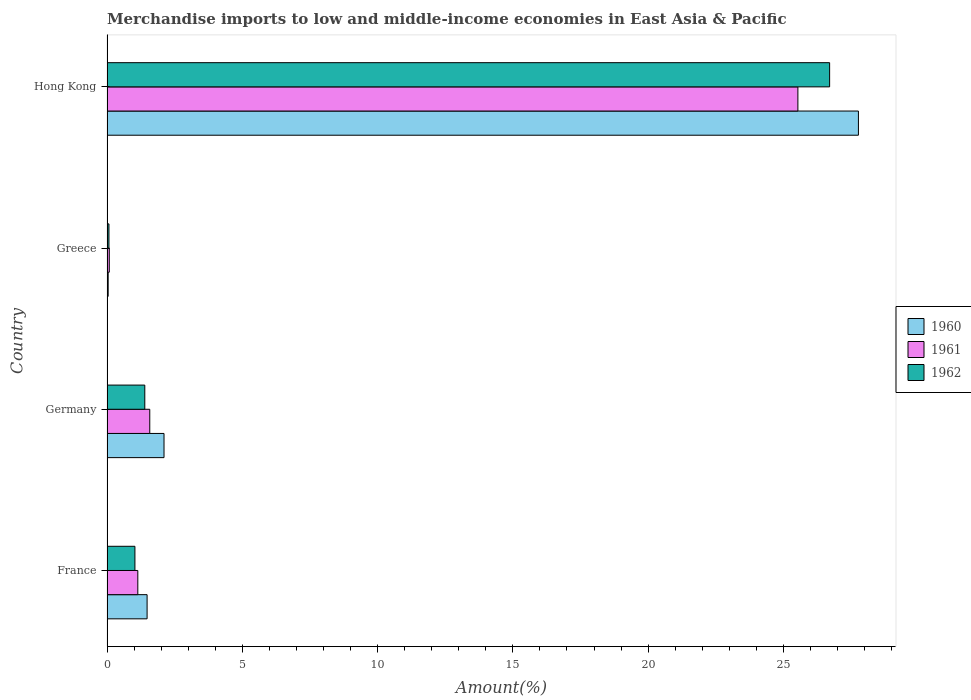How many different coloured bars are there?
Provide a short and direct response. 3. How many groups of bars are there?
Your answer should be very brief. 4. Are the number of bars on each tick of the Y-axis equal?
Provide a short and direct response. Yes. In how many cases, is the number of bars for a given country not equal to the number of legend labels?
Your response must be concise. 0. What is the percentage of amount earned from merchandise imports in 1961 in France?
Offer a very short reply. 1.14. Across all countries, what is the maximum percentage of amount earned from merchandise imports in 1961?
Offer a very short reply. 25.53. Across all countries, what is the minimum percentage of amount earned from merchandise imports in 1960?
Provide a succinct answer. 0.04. In which country was the percentage of amount earned from merchandise imports in 1962 maximum?
Your answer should be compact. Hong Kong. What is the total percentage of amount earned from merchandise imports in 1961 in the graph?
Provide a succinct answer. 28.34. What is the difference between the percentage of amount earned from merchandise imports in 1962 in Germany and that in Greece?
Give a very brief answer. 1.33. What is the difference between the percentage of amount earned from merchandise imports in 1962 in Hong Kong and the percentage of amount earned from merchandise imports in 1960 in France?
Give a very brief answer. 25.23. What is the average percentage of amount earned from merchandise imports in 1961 per country?
Offer a terse response. 7.08. What is the difference between the percentage of amount earned from merchandise imports in 1961 and percentage of amount earned from merchandise imports in 1962 in Greece?
Provide a short and direct response. 0.01. What is the ratio of the percentage of amount earned from merchandise imports in 1960 in Germany to that in Greece?
Provide a succinct answer. 49.05. What is the difference between the highest and the second highest percentage of amount earned from merchandise imports in 1961?
Your answer should be very brief. 23.95. What is the difference between the highest and the lowest percentage of amount earned from merchandise imports in 1962?
Offer a terse response. 26.64. What does the 1st bar from the bottom in Hong Kong represents?
Give a very brief answer. 1960. How many bars are there?
Offer a very short reply. 12. Are all the bars in the graph horizontal?
Provide a succinct answer. Yes. How many legend labels are there?
Give a very brief answer. 3. What is the title of the graph?
Offer a very short reply. Merchandise imports to low and middle-income economies in East Asia & Pacific. Does "2007" appear as one of the legend labels in the graph?
Your answer should be compact. No. What is the label or title of the X-axis?
Offer a terse response. Amount(%). What is the label or title of the Y-axis?
Your response must be concise. Country. What is the Amount(%) in 1960 in France?
Offer a very short reply. 1.48. What is the Amount(%) of 1961 in France?
Your response must be concise. 1.14. What is the Amount(%) of 1962 in France?
Offer a terse response. 1.03. What is the Amount(%) in 1960 in Germany?
Provide a short and direct response. 2.11. What is the Amount(%) in 1961 in Germany?
Provide a short and direct response. 1.58. What is the Amount(%) of 1962 in Germany?
Provide a short and direct response. 1.4. What is the Amount(%) in 1960 in Greece?
Provide a short and direct response. 0.04. What is the Amount(%) of 1961 in Greece?
Offer a terse response. 0.08. What is the Amount(%) of 1962 in Greece?
Offer a very short reply. 0.07. What is the Amount(%) of 1960 in Hong Kong?
Keep it short and to the point. 27.77. What is the Amount(%) in 1961 in Hong Kong?
Offer a very short reply. 25.53. What is the Amount(%) of 1962 in Hong Kong?
Offer a terse response. 26.71. Across all countries, what is the maximum Amount(%) of 1960?
Your answer should be very brief. 27.77. Across all countries, what is the maximum Amount(%) in 1961?
Keep it short and to the point. 25.53. Across all countries, what is the maximum Amount(%) in 1962?
Provide a short and direct response. 26.71. Across all countries, what is the minimum Amount(%) in 1960?
Provide a short and direct response. 0.04. Across all countries, what is the minimum Amount(%) of 1961?
Offer a terse response. 0.08. Across all countries, what is the minimum Amount(%) of 1962?
Keep it short and to the point. 0.07. What is the total Amount(%) in 1960 in the graph?
Ensure brevity in your answer.  31.4. What is the total Amount(%) in 1961 in the graph?
Keep it short and to the point. 28.34. What is the total Amount(%) of 1962 in the graph?
Make the answer very short. 29.21. What is the difference between the Amount(%) of 1960 in France and that in Germany?
Make the answer very short. -0.63. What is the difference between the Amount(%) of 1961 in France and that in Germany?
Your answer should be compact. -0.44. What is the difference between the Amount(%) of 1962 in France and that in Germany?
Give a very brief answer. -0.36. What is the difference between the Amount(%) in 1960 in France and that in Greece?
Your response must be concise. 1.44. What is the difference between the Amount(%) in 1961 in France and that in Greece?
Offer a terse response. 1.05. What is the difference between the Amount(%) of 1962 in France and that in Greece?
Give a very brief answer. 0.96. What is the difference between the Amount(%) in 1960 in France and that in Hong Kong?
Give a very brief answer. -26.29. What is the difference between the Amount(%) of 1961 in France and that in Hong Kong?
Your response must be concise. -24.4. What is the difference between the Amount(%) of 1962 in France and that in Hong Kong?
Keep it short and to the point. -25.68. What is the difference between the Amount(%) in 1960 in Germany and that in Greece?
Make the answer very short. 2.06. What is the difference between the Amount(%) of 1961 in Germany and that in Greece?
Give a very brief answer. 1.5. What is the difference between the Amount(%) in 1962 in Germany and that in Greece?
Provide a succinct answer. 1.33. What is the difference between the Amount(%) in 1960 in Germany and that in Hong Kong?
Offer a very short reply. -25.66. What is the difference between the Amount(%) in 1961 in Germany and that in Hong Kong?
Your response must be concise. -23.95. What is the difference between the Amount(%) of 1962 in Germany and that in Hong Kong?
Provide a succinct answer. -25.31. What is the difference between the Amount(%) of 1960 in Greece and that in Hong Kong?
Give a very brief answer. -27.73. What is the difference between the Amount(%) in 1961 in Greece and that in Hong Kong?
Your response must be concise. -25.45. What is the difference between the Amount(%) of 1962 in Greece and that in Hong Kong?
Offer a terse response. -26.64. What is the difference between the Amount(%) in 1960 in France and the Amount(%) in 1961 in Germany?
Keep it short and to the point. -0.1. What is the difference between the Amount(%) in 1960 in France and the Amount(%) in 1962 in Germany?
Keep it short and to the point. 0.08. What is the difference between the Amount(%) of 1961 in France and the Amount(%) of 1962 in Germany?
Your response must be concise. -0.26. What is the difference between the Amount(%) of 1960 in France and the Amount(%) of 1961 in Greece?
Provide a succinct answer. 1.4. What is the difference between the Amount(%) of 1960 in France and the Amount(%) of 1962 in Greece?
Your response must be concise. 1.41. What is the difference between the Amount(%) in 1961 in France and the Amount(%) in 1962 in Greece?
Offer a terse response. 1.07. What is the difference between the Amount(%) of 1960 in France and the Amount(%) of 1961 in Hong Kong?
Make the answer very short. -24.05. What is the difference between the Amount(%) of 1960 in France and the Amount(%) of 1962 in Hong Kong?
Keep it short and to the point. -25.23. What is the difference between the Amount(%) of 1961 in France and the Amount(%) of 1962 in Hong Kong?
Provide a succinct answer. -25.57. What is the difference between the Amount(%) of 1960 in Germany and the Amount(%) of 1961 in Greece?
Offer a very short reply. 2.02. What is the difference between the Amount(%) in 1960 in Germany and the Amount(%) in 1962 in Greece?
Ensure brevity in your answer.  2.04. What is the difference between the Amount(%) in 1961 in Germany and the Amount(%) in 1962 in Greece?
Offer a terse response. 1.51. What is the difference between the Amount(%) in 1960 in Germany and the Amount(%) in 1961 in Hong Kong?
Offer a very short reply. -23.43. What is the difference between the Amount(%) in 1960 in Germany and the Amount(%) in 1962 in Hong Kong?
Your response must be concise. -24.6. What is the difference between the Amount(%) in 1961 in Germany and the Amount(%) in 1962 in Hong Kong?
Keep it short and to the point. -25.13. What is the difference between the Amount(%) in 1960 in Greece and the Amount(%) in 1961 in Hong Kong?
Provide a succinct answer. -25.49. What is the difference between the Amount(%) in 1960 in Greece and the Amount(%) in 1962 in Hong Kong?
Make the answer very short. -26.66. What is the difference between the Amount(%) in 1961 in Greece and the Amount(%) in 1962 in Hong Kong?
Make the answer very short. -26.62. What is the average Amount(%) in 1960 per country?
Provide a succinct answer. 7.85. What is the average Amount(%) of 1961 per country?
Keep it short and to the point. 7.08. What is the average Amount(%) in 1962 per country?
Offer a terse response. 7.3. What is the difference between the Amount(%) in 1960 and Amount(%) in 1961 in France?
Keep it short and to the point. 0.34. What is the difference between the Amount(%) in 1960 and Amount(%) in 1962 in France?
Offer a very short reply. 0.45. What is the difference between the Amount(%) of 1961 and Amount(%) of 1962 in France?
Provide a succinct answer. 0.11. What is the difference between the Amount(%) of 1960 and Amount(%) of 1961 in Germany?
Offer a very short reply. 0.53. What is the difference between the Amount(%) of 1960 and Amount(%) of 1962 in Germany?
Offer a very short reply. 0.71. What is the difference between the Amount(%) in 1961 and Amount(%) in 1962 in Germany?
Provide a succinct answer. 0.18. What is the difference between the Amount(%) in 1960 and Amount(%) in 1961 in Greece?
Your answer should be very brief. -0.04. What is the difference between the Amount(%) of 1960 and Amount(%) of 1962 in Greece?
Keep it short and to the point. -0.03. What is the difference between the Amount(%) in 1961 and Amount(%) in 1962 in Greece?
Your answer should be very brief. 0.01. What is the difference between the Amount(%) of 1960 and Amount(%) of 1961 in Hong Kong?
Offer a terse response. 2.24. What is the difference between the Amount(%) in 1960 and Amount(%) in 1962 in Hong Kong?
Provide a short and direct response. 1.06. What is the difference between the Amount(%) in 1961 and Amount(%) in 1962 in Hong Kong?
Make the answer very short. -1.17. What is the ratio of the Amount(%) of 1960 in France to that in Germany?
Offer a terse response. 0.7. What is the ratio of the Amount(%) of 1961 in France to that in Germany?
Give a very brief answer. 0.72. What is the ratio of the Amount(%) in 1962 in France to that in Germany?
Give a very brief answer. 0.74. What is the ratio of the Amount(%) of 1960 in France to that in Greece?
Your answer should be compact. 34.49. What is the ratio of the Amount(%) in 1961 in France to that in Greece?
Your answer should be compact. 13.48. What is the ratio of the Amount(%) of 1962 in France to that in Greece?
Keep it short and to the point. 14.37. What is the ratio of the Amount(%) in 1960 in France to that in Hong Kong?
Make the answer very short. 0.05. What is the ratio of the Amount(%) of 1961 in France to that in Hong Kong?
Make the answer very short. 0.04. What is the ratio of the Amount(%) in 1962 in France to that in Hong Kong?
Offer a very short reply. 0.04. What is the ratio of the Amount(%) of 1960 in Germany to that in Greece?
Give a very brief answer. 49.05. What is the ratio of the Amount(%) of 1961 in Germany to that in Greece?
Ensure brevity in your answer.  18.72. What is the ratio of the Amount(%) in 1962 in Germany to that in Greece?
Provide a short and direct response. 19.46. What is the ratio of the Amount(%) in 1960 in Germany to that in Hong Kong?
Keep it short and to the point. 0.08. What is the ratio of the Amount(%) of 1961 in Germany to that in Hong Kong?
Keep it short and to the point. 0.06. What is the ratio of the Amount(%) of 1962 in Germany to that in Hong Kong?
Give a very brief answer. 0.05. What is the ratio of the Amount(%) in 1960 in Greece to that in Hong Kong?
Provide a succinct answer. 0. What is the ratio of the Amount(%) in 1961 in Greece to that in Hong Kong?
Your response must be concise. 0. What is the ratio of the Amount(%) of 1962 in Greece to that in Hong Kong?
Give a very brief answer. 0. What is the difference between the highest and the second highest Amount(%) of 1960?
Keep it short and to the point. 25.66. What is the difference between the highest and the second highest Amount(%) in 1961?
Provide a succinct answer. 23.95. What is the difference between the highest and the second highest Amount(%) in 1962?
Make the answer very short. 25.31. What is the difference between the highest and the lowest Amount(%) in 1960?
Give a very brief answer. 27.73. What is the difference between the highest and the lowest Amount(%) in 1961?
Your response must be concise. 25.45. What is the difference between the highest and the lowest Amount(%) in 1962?
Your answer should be very brief. 26.64. 